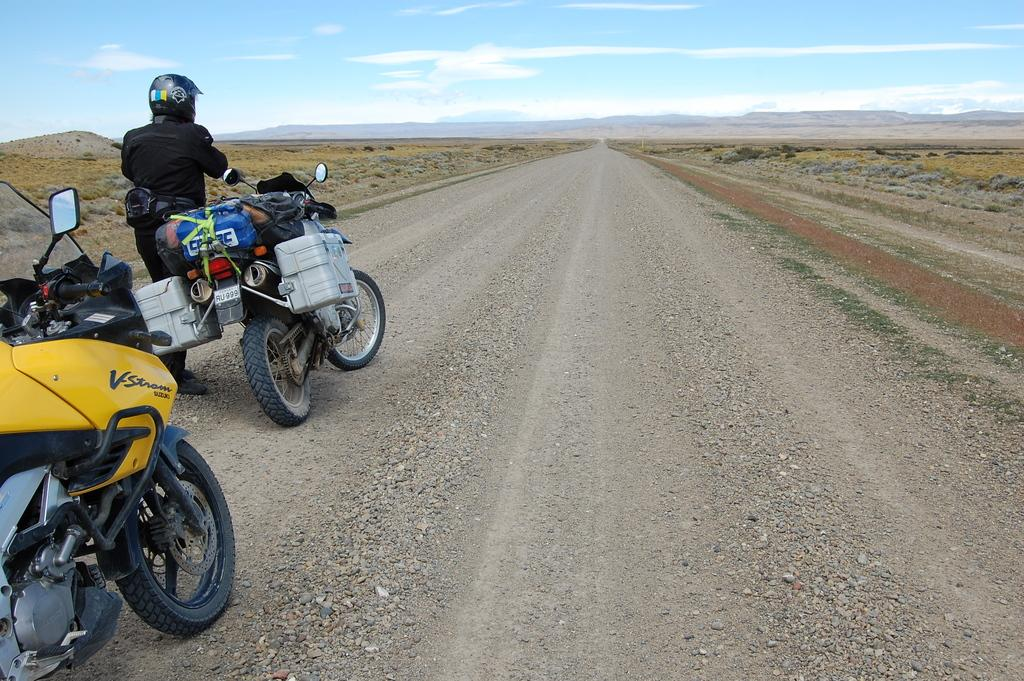What is located on the left side of the image? There are likes on the left side of the image, and there are also persons on the road. What can be seen in the background of the image? There is a road, trees, plants, hills, and the sky visible in the background of the image. What is the condition of the sky in the image? The sky is visible in the background of the image, and clouds are present. Can you tell me how many brushes are used to paint the hills in the image? There are no brushes present in the image, and the hills are not painted. What type of vein is visible in the image? There are no veins visible in the image; it features a road, trees, plants, hills, and the sky. 